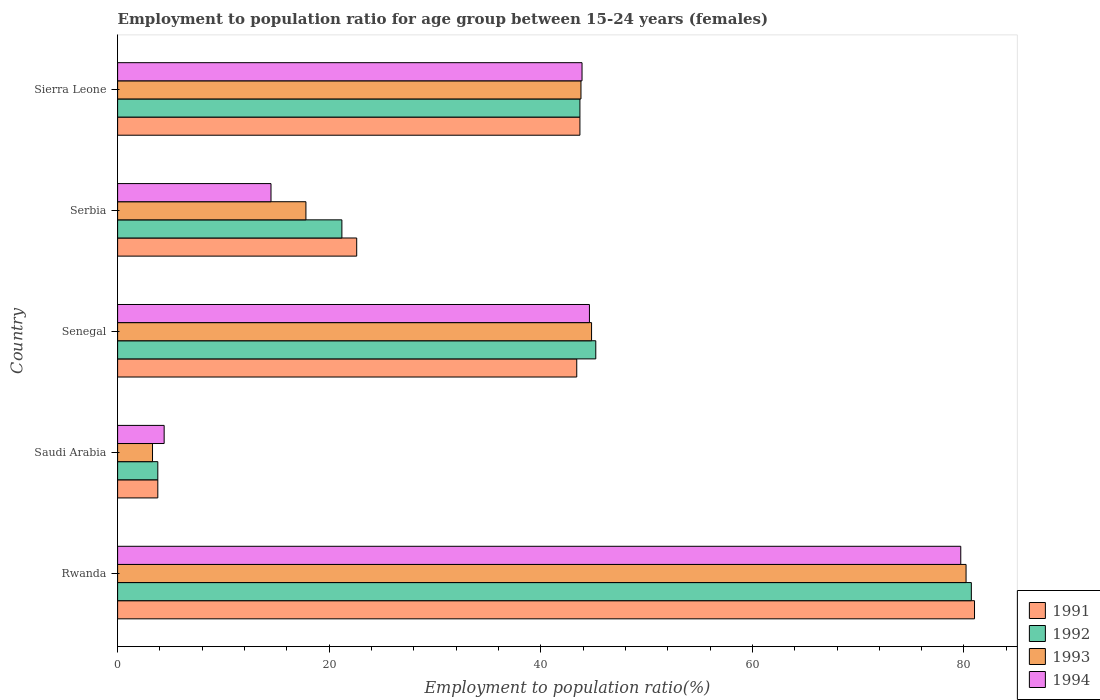How many different coloured bars are there?
Ensure brevity in your answer.  4. How many groups of bars are there?
Ensure brevity in your answer.  5. Are the number of bars per tick equal to the number of legend labels?
Provide a short and direct response. Yes. Are the number of bars on each tick of the Y-axis equal?
Make the answer very short. Yes. What is the label of the 3rd group of bars from the top?
Make the answer very short. Senegal. In how many cases, is the number of bars for a given country not equal to the number of legend labels?
Your answer should be compact. 0. What is the employment to population ratio in 1994 in Senegal?
Your answer should be compact. 44.6. Across all countries, what is the maximum employment to population ratio in 1994?
Your answer should be compact. 79.7. Across all countries, what is the minimum employment to population ratio in 1991?
Your answer should be compact. 3.8. In which country was the employment to population ratio in 1992 maximum?
Your answer should be very brief. Rwanda. In which country was the employment to population ratio in 1992 minimum?
Keep it short and to the point. Saudi Arabia. What is the total employment to population ratio in 1994 in the graph?
Provide a succinct answer. 187.1. What is the difference between the employment to population ratio in 1991 in Rwanda and that in Sierra Leone?
Your answer should be very brief. 37.3. What is the difference between the employment to population ratio in 1994 in Rwanda and the employment to population ratio in 1992 in Senegal?
Offer a terse response. 34.5. What is the average employment to population ratio in 1992 per country?
Offer a very short reply. 38.92. What is the difference between the employment to population ratio in 1994 and employment to population ratio in 1993 in Sierra Leone?
Keep it short and to the point. 0.1. What is the ratio of the employment to population ratio in 1993 in Rwanda to that in Serbia?
Give a very brief answer. 4.51. Is the employment to population ratio in 1991 in Serbia less than that in Sierra Leone?
Offer a very short reply. Yes. Is the difference between the employment to population ratio in 1994 in Senegal and Sierra Leone greater than the difference between the employment to population ratio in 1993 in Senegal and Sierra Leone?
Provide a succinct answer. No. What is the difference between the highest and the second highest employment to population ratio in 1992?
Keep it short and to the point. 35.5. What is the difference between the highest and the lowest employment to population ratio in 1994?
Your response must be concise. 75.3. Is it the case that in every country, the sum of the employment to population ratio in 1994 and employment to population ratio in 1992 is greater than the sum of employment to population ratio in 1993 and employment to population ratio in 1991?
Offer a very short reply. No. Is it the case that in every country, the sum of the employment to population ratio in 1993 and employment to population ratio in 1991 is greater than the employment to population ratio in 1992?
Give a very brief answer. Yes. How many bars are there?
Make the answer very short. 20. Does the graph contain any zero values?
Your answer should be compact. No. Where does the legend appear in the graph?
Provide a short and direct response. Bottom right. How are the legend labels stacked?
Provide a short and direct response. Vertical. What is the title of the graph?
Offer a very short reply. Employment to population ratio for age group between 15-24 years (females). What is the Employment to population ratio(%) in 1992 in Rwanda?
Give a very brief answer. 80.7. What is the Employment to population ratio(%) of 1993 in Rwanda?
Your answer should be very brief. 80.2. What is the Employment to population ratio(%) in 1994 in Rwanda?
Make the answer very short. 79.7. What is the Employment to population ratio(%) in 1991 in Saudi Arabia?
Keep it short and to the point. 3.8. What is the Employment to population ratio(%) of 1992 in Saudi Arabia?
Keep it short and to the point. 3.8. What is the Employment to population ratio(%) in 1993 in Saudi Arabia?
Make the answer very short. 3.3. What is the Employment to population ratio(%) in 1994 in Saudi Arabia?
Your answer should be very brief. 4.4. What is the Employment to population ratio(%) of 1991 in Senegal?
Provide a succinct answer. 43.4. What is the Employment to population ratio(%) of 1992 in Senegal?
Ensure brevity in your answer.  45.2. What is the Employment to population ratio(%) in 1993 in Senegal?
Ensure brevity in your answer.  44.8. What is the Employment to population ratio(%) of 1994 in Senegal?
Offer a terse response. 44.6. What is the Employment to population ratio(%) in 1991 in Serbia?
Offer a terse response. 22.6. What is the Employment to population ratio(%) in 1992 in Serbia?
Ensure brevity in your answer.  21.2. What is the Employment to population ratio(%) in 1993 in Serbia?
Give a very brief answer. 17.8. What is the Employment to population ratio(%) of 1994 in Serbia?
Provide a succinct answer. 14.5. What is the Employment to population ratio(%) in 1991 in Sierra Leone?
Keep it short and to the point. 43.7. What is the Employment to population ratio(%) in 1992 in Sierra Leone?
Give a very brief answer. 43.7. What is the Employment to population ratio(%) in 1993 in Sierra Leone?
Your answer should be compact. 43.8. What is the Employment to population ratio(%) of 1994 in Sierra Leone?
Ensure brevity in your answer.  43.9. Across all countries, what is the maximum Employment to population ratio(%) of 1991?
Your answer should be very brief. 81. Across all countries, what is the maximum Employment to population ratio(%) of 1992?
Keep it short and to the point. 80.7. Across all countries, what is the maximum Employment to population ratio(%) in 1993?
Offer a very short reply. 80.2. Across all countries, what is the maximum Employment to population ratio(%) in 1994?
Make the answer very short. 79.7. Across all countries, what is the minimum Employment to population ratio(%) in 1991?
Provide a short and direct response. 3.8. Across all countries, what is the minimum Employment to population ratio(%) in 1992?
Offer a very short reply. 3.8. Across all countries, what is the minimum Employment to population ratio(%) of 1993?
Give a very brief answer. 3.3. Across all countries, what is the minimum Employment to population ratio(%) of 1994?
Your answer should be compact. 4.4. What is the total Employment to population ratio(%) in 1991 in the graph?
Your answer should be very brief. 194.5. What is the total Employment to population ratio(%) of 1992 in the graph?
Give a very brief answer. 194.6. What is the total Employment to population ratio(%) in 1993 in the graph?
Your response must be concise. 189.9. What is the total Employment to population ratio(%) in 1994 in the graph?
Provide a short and direct response. 187.1. What is the difference between the Employment to population ratio(%) in 1991 in Rwanda and that in Saudi Arabia?
Provide a short and direct response. 77.2. What is the difference between the Employment to population ratio(%) of 1992 in Rwanda and that in Saudi Arabia?
Make the answer very short. 76.9. What is the difference between the Employment to population ratio(%) in 1993 in Rwanda and that in Saudi Arabia?
Your response must be concise. 76.9. What is the difference between the Employment to population ratio(%) in 1994 in Rwanda and that in Saudi Arabia?
Offer a terse response. 75.3. What is the difference between the Employment to population ratio(%) of 1991 in Rwanda and that in Senegal?
Make the answer very short. 37.6. What is the difference between the Employment to population ratio(%) of 1992 in Rwanda and that in Senegal?
Give a very brief answer. 35.5. What is the difference between the Employment to population ratio(%) in 1993 in Rwanda and that in Senegal?
Your response must be concise. 35.4. What is the difference between the Employment to population ratio(%) of 1994 in Rwanda and that in Senegal?
Provide a succinct answer. 35.1. What is the difference between the Employment to population ratio(%) in 1991 in Rwanda and that in Serbia?
Offer a very short reply. 58.4. What is the difference between the Employment to population ratio(%) in 1992 in Rwanda and that in Serbia?
Ensure brevity in your answer.  59.5. What is the difference between the Employment to population ratio(%) of 1993 in Rwanda and that in Serbia?
Offer a terse response. 62.4. What is the difference between the Employment to population ratio(%) in 1994 in Rwanda and that in Serbia?
Provide a short and direct response. 65.2. What is the difference between the Employment to population ratio(%) in 1991 in Rwanda and that in Sierra Leone?
Ensure brevity in your answer.  37.3. What is the difference between the Employment to population ratio(%) in 1992 in Rwanda and that in Sierra Leone?
Your answer should be very brief. 37. What is the difference between the Employment to population ratio(%) in 1993 in Rwanda and that in Sierra Leone?
Give a very brief answer. 36.4. What is the difference between the Employment to population ratio(%) in 1994 in Rwanda and that in Sierra Leone?
Your answer should be very brief. 35.8. What is the difference between the Employment to population ratio(%) in 1991 in Saudi Arabia and that in Senegal?
Offer a terse response. -39.6. What is the difference between the Employment to population ratio(%) in 1992 in Saudi Arabia and that in Senegal?
Keep it short and to the point. -41.4. What is the difference between the Employment to population ratio(%) in 1993 in Saudi Arabia and that in Senegal?
Ensure brevity in your answer.  -41.5. What is the difference between the Employment to population ratio(%) in 1994 in Saudi Arabia and that in Senegal?
Provide a short and direct response. -40.2. What is the difference between the Employment to population ratio(%) of 1991 in Saudi Arabia and that in Serbia?
Give a very brief answer. -18.8. What is the difference between the Employment to population ratio(%) in 1992 in Saudi Arabia and that in Serbia?
Your answer should be compact. -17.4. What is the difference between the Employment to population ratio(%) of 1993 in Saudi Arabia and that in Serbia?
Provide a succinct answer. -14.5. What is the difference between the Employment to population ratio(%) of 1994 in Saudi Arabia and that in Serbia?
Provide a succinct answer. -10.1. What is the difference between the Employment to population ratio(%) of 1991 in Saudi Arabia and that in Sierra Leone?
Provide a succinct answer. -39.9. What is the difference between the Employment to population ratio(%) of 1992 in Saudi Arabia and that in Sierra Leone?
Your answer should be compact. -39.9. What is the difference between the Employment to population ratio(%) in 1993 in Saudi Arabia and that in Sierra Leone?
Your response must be concise. -40.5. What is the difference between the Employment to population ratio(%) of 1994 in Saudi Arabia and that in Sierra Leone?
Keep it short and to the point. -39.5. What is the difference between the Employment to population ratio(%) in 1991 in Senegal and that in Serbia?
Ensure brevity in your answer.  20.8. What is the difference between the Employment to population ratio(%) in 1994 in Senegal and that in Serbia?
Provide a succinct answer. 30.1. What is the difference between the Employment to population ratio(%) of 1991 in Serbia and that in Sierra Leone?
Provide a succinct answer. -21.1. What is the difference between the Employment to population ratio(%) in 1992 in Serbia and that in Sierra Leone?
Give a very brief answer. -22.5. What is the difference between the Employment to population ratio(%) in 1993 in Serbia and that in Sierra Leone?
Give a very brief answer. -26. What is the difference between the Employment to population ratio(%) in 1994 in Serbia and that in Sierra Leone?
Provide a short and direct response. -29.4. What is the difference between the Employment to population ratio(%) of 1991 in Rwanda and the Employment to population ratio(%) of 1992 in Saudi Arabia?
Your response must be concise. 77.2. What is the difference between the Employment to population ratio(%) in 1991 in Rwanda and the Employment to population ratio(%) in 1993 in Saudi Arabia?
Your answer should be compact. 77.7. What is the difference between the Employment to population ratio(%) of 1991 in Rwanda and the Employment to population ratio(%) of 1994 in Saudi Arabia?
Provide a succinct answer. 76.6. What is the difference between the Employment to population ratio(%) of 1992 in Rwanda and the Employment to population ratio(%) of 1993 in Saudi Arabia?
Offer a very short reply. 77.4. What is the difference between the Employment to population ratio(%) in 1992 in Rwanda and the Employment to population ratio(%) in 1994 in Saudi Arabia?
Ensure brevity in your answer.  76.3. What is the difference between the Employment to population ratio(%) of 1993 in Rwanda and the Employment to population ratio(%) of 1994 in Saudi Arabia?
Your answer should be compact. 75.8. What is the difference between the Employment to population ratio(%) in 1991 in Rwanda and the Employment to population ratio(%) in 1992 in Senegal?
Give a very brief answer. 35.8. What is the difference between the Employment to population ratio(%) in 1991 in Rwanda and the Employment to population ratio(%) in 1993 in Senegal?
Ensure brevity in your answer.  36.2. What is the difference between the Employment to population ratio(%) in 1991 in Rwanda and the Employment to population ratio(%) in 1994 in Senegal?
Your answer should be compact. 36.4. What is the difference between the Employment to population ratio(%) of 1992 in Rwanda and the Employment to population ratio(%) of 1993 in Senegal?
Provide a short and direct response. 35.9. What is the difference between the Employment to population ratio(%) in 1992 in Rwanda and the Employment to population ratio(%) in 1994 in Senegal?
Your answer should be compact. 36.1. What is the difference between the Employment to population ratio(%) of 1993 in Rwanda and the Employment to population ratio(%) of 1994 in Senegal?
Your answer should be very brief. 35.6. What is the difference between the Employment to population ratio(%) in 1991 in Rwanda and the Employment to population ratio(%) in 1992 in Serbia?
Your answer should be compact. 59.8. What is the difference between the Employment to population ratio(%) of 1991 in Rwanda and the Employment to population ratio(%) of 1993 in Serbia?
Your response must be concise. 63.2. What is the difference between the Employment to population ratio(%) of 1991 in Rwanda and the Employment to population ratio(%) of 1994 in Serbia?
Your answer should be very brief. 66.5. What is the difference between the Employment to population ratio(%) in 1992 in Rwanda and the Employment to population ratio(%) in 1993 in Serbia?
Provide a succinct answer. 62.9. What is the difference between the Employment to population ratio(%) of 1992 in Rwanda and the Employment to population ratio(%) of 1994 in Serbia?
Give a very brief answer. 66.2. What is the difference between the Employment to population ratio(%) of 1993 in Rwanda and the Employment to population ratio(%) of 1994 in Serbia?
Offer a very short reply. 65.7. What is the difference between the Employment to population ratio(%) of 1991 in Rwanda and the Employment to population ratio(%) of 1992 in Sierra Leone?
Keep it short and to the point. 37.3. What is the difference between the Employment to population ratio(%) of 1991 in Rwanda and the Employment to population ratio(%) of 1993 in Sierra Leone?
Your response must be concise. 37.2. What is the difference between the Employment to population ratio(%) in 1991 in Rwanda and the Employment to population ratio(%) in 1994 in Sierra Leone?
Offer a very short reply. 37.1. What is the difference between the Employment to population ratio(%) in 1992 in Rwanda and the Employment to population ratio(%) in 1993 in Sierra Leone?
Provide a succinct answer. 36.9. What is the difference between the Employment to population ratio(%) of 1992 in Rwanda and the Employment to population ratio(%) of 1994 in Sierra Leone?
Give a very brief answer. 36.8. What is the difference between the Employment to population ratio(%) in 1993 in Rwanda and the Employment to population ratio(%) in 1994 in Sierra Leone?
Provide a succinct answer. 36.3. What is the difference between the Employment to population ratio(%) of 1991 in Saudi Arabia and the Employment to population ratio(%) of 1992 in Senegal?
Ensure brevity in your answer.  -41.4. What is the difference between the Employment to population ratio(%) of 1991 in Saudi Arabia and the Employment to population ratio(%) of 1993 in Senegal?
Offer a very short reply. -41. What is the difference between the Employment to population ratio(%) of 1991 in Saudi Arabia and the Employment to population ratio(%) of 1994 in Senegal?
Your answer should be very brief. -40.8. What is the difference between the Employment to population ratio(%) of 1992 in Saudi Arabia and the Employment to population ratio(%) of 1993 in Senegal?
Your response must be concise. -41. What is the difference between the Employment to population ratio(%) of 1992 in Saudi Arabia and the Employment to population ratio(%) of 1994 in Senegal?
Ensure brevity in your answer.  -40.8. What is the difference between the Employment to population ratio(%) of 1993 in Saudi Arabia and the Employment to population ratio(%) of 1994 in Senegal?
Provide a succinct answer. -41.3. What is the difference between the Employment to population ratio(%) of 1991 in Saudi Arabia and the Employment to population ratio(%) of 1992 in Serbia?
Offer a terse response. -17.4. What is the difference between the Employment to population ratio(%) in 1991 in Saudi Arabia and the Employment to population ratio(%) in 1993 in Serbia?
Offer a very short reply. -14. What is the difference between the Employment to population ratio(%) of 1993 in Saudi Arabia and the Employment to population ratio(%) of 1994 in Serbia?
Keep it short and to the point. -11.2. What is the difference between the Employment to population ratio(%) of 1991 in Saudi Arabia and the Employment to population ratio(%) of 1992 in Sierra Leone?
Give a very brief answer. -39.9. What is the difference between the Employment to population ratio(%) in 1991 in Saudi Arabia and the Employment to population ratio(%) in 1993 in Sierra Leone?
Your answer should be compact. -40. What is the difference between the Employment to population ratio(%) of 1991 in Saudi Arabia and the Employment to population ratio(%) of 1994 in Sierra Leone?
Provide a short and direct response. -40.1. What is the difference between the Employment to population ratio(%) in 1992 in Saudi Arabia and the Employment to population ratio(%) in 1994 in Sierra Leone?
Provide a short and direct response. -40.1. What is the difference between the Employment to population ratio(%) of 1993 in Saudi Arabia and the Employment to population ratio(%) of 1994 in Sierra Leone?
Make the answer very short. -40.6. What is the difference between the Employment to population ratio(%) of 1991 in Senegal and the Employment to population ratio(%) of 1992 in Serbia?
Your answer should be compact. 22.2. What is the difference between the Employment to population ratio(%) of 1991 in Senegal and the Employment to population ratio(%) of 1993 in Serbia?
Offer a terse response. 25.6. What is the difference between the Employment to population ratio(%) in 1991 in Senegal and the Employment to population ratio(%) in 1994 in Serbia?
Offer a terse response. 28.9. What is the difference between the Employment to population ratio(%) of 1992 in Senegal and the Employment to population ratio(%) of 1993 in Serbia?
Give a very brief answer. 27.4. What is the difference between the Employment to population ratio(%) in 1992 in Senegal and the Employment to population ratio(%) in 1994 in Serbia?
Provide a short and direct response. 30.7. What is the difference between the Employment to population ratio(%) of 1993 in Senegal and the Employment to population ratio(%) of 1994 in Serbia?
Your answer should be compact. 30.3. What is the difference between the Employment to population ratio(%) of 1991 in Senegal and the Employment to population ratio(%) of 1992 in Sierra Leone?
Give a very brief answer. -0.3. What is the difference between the Employment to population ratio(%) of 1991 in Senegal and the Employment to population ratio(%) of 1993 in Sierra Leone?
Provide a short and direct response. -0.4. What is the difference between the Employment to population ratio(%) in 1992 in Senegal and the Employment to population ratio(%) in 1993 in Sierra Leone?
Give a very brief answer. 1.4. What is the difference between the Employment to population ratio(%) of 1992 in Senegal and the Employment to population ratio(%) of 1994 in Sierra Leone?
Provide a short and direct response. 1.3. What is the difference between the Employment to population ratio(%) of 1993 in Senegal and the Employment to population ratio(%) of 1994 in Sierra Leone?
Ensure brevity in your answer.  0.9. What is the difference between the Employment to population ratio(%) in 1991 in Serbia and the Employment to population ratio(%) in 1992 in Sierra Leone?
Your response must be concise. -21.1. What is the difference between the Employment to population ratio(%) in 1991 in Serbia and the Employment to population ratio(%) in 1993 in Sierra Leone?
Ensure brevity in your answer.  -21.2. What is the difference between the Employment to population ratio(%) of 1991 in Serbia and the Employment to population ratio(%) of 1994 in Sierra Leone?
Make the answer very short. -21.3. What is the difference between the Employment to population ratio(%) of 1992 in Serbia and the Employment to population ratio(%) of 1993 in Sierra Leone?
Your response must be concise. -22.6. What is the difference between the Employment to population ratio(%) in 1992 in Serbia and the Employment to population ratio(%) in 1994 in Sierra Leone?
Provide a succinct answer. -22.7. What is the difference between the Employment to population ratio(%) of 1993 in Serbia and the Employment to population ratio(%) of 1994 in Sierra Leone?
Offer a very short reply. -26.1. What is the average Employment to population ratio(%) in 1991 per country?
Provide a succinct answer. 38.9. What is the average Employment to population ratio(%) in 1992 per country?
Your answer should be compact. 38.92. What is the average Employment to population ratio(%) of 1993 per country?
Your response must be concise. 37.98. What is the average Employment to population ratio(%) in 1994 per country?
Make the answer very short. 37.42. What is the difference between the Employment to population ratio(%) of 1991 and Employment to population ratio(%) of 1992 in Rwanda?
Give a very brief answer. 0.3. What is the difference between the Employment to population ratio(%) of 1992 and Employment to population ratio(%) of 1993 in Rwanda?
Offer a terse response. 0.5. What is the difference between the Employment to population ratio(%) of 1991 and Employment to population ratio(%) of 1993 in Saudi Arabia?
Your answer should be very brief. 0.5. What is the difference between the Employment to population ratio(%) of 1992 and Employment to population ratio(%) of 1994 in Saudi Arabia?
Give a very brief answer. -0.6. What is the difference between the Employment to population ratio(%) of 1993 and Employment to population ratio(%) of 1994 in Saudi Arabia?
Your answer should be compact. -1.1. What is the difference between the Employment to population ratio(%) in 1991 and Employment to population ratio(%) in 1993 in Senegal?
Provide a succinct answer. -1.4. What is the difference between the Employment to population ratio(%) in 1992 and Employment to population ratio(%) in 1993 in Senegal?
Keep it short and to the point. 0.4. What is the difference between the Employment to population ratio(%) in 1993 and Employment to population ratio(%) in 1994 in Senegal?
Provide a succinct answer. 0.2. What is the difference between the Employment to population ratio(%) in 1991 and Employment to population ratio(%) in 1992 in Serbia?
Provide a succinct answer. 1.4. What is the difference between the Employment to population ratio(%) in 1991 and Employment to population ratio(%) in 1993 in Serbia?
Your answer should be very brief. 4.8. What is the difference between the Employment to population ratio(%) in 1991 and Employment to population ratio(%) in 1994 in Serbia?
Ensure brevity in your answer.  8.1. What is the difference between the Employment to population ratio(%) in 1992 and Employment to population ratio(%) in 1993 in Serbia?
Make the answer very short. 3.4. What is the difference between the Employment to population ratio(%) of 1991 and Employment to population ratio(%) of 1994 in Sierra Leone?
Keep it short and to the point. -0.2. What is the difference between the Employment to population ratio(%) of 1992 and Employment to population ratio(%) of 1994 in Sierra Leone?
Ensure brevity in your answer.  -0.2. What is the ratio of the Employment to population ratio(%) in 1991 in Rwanda to that in Saudi Arabia?
Your answer should be very brief. 21.32. What is the ratio of the Employment to population ratio(%) of 1992 in Rwanda to that in Saudi Arabia?
Your response must be concise. 21.24. What is the ratio of the Employment to population ratio(%) in 1993 in Rwanda to that in Saudi Arabia?
Provide a short and direct response. 24.3. What is the ratio of the Employment to population ratio(%) in 1994 in Rwanda to that in Saudi Arabia?
Give a very brief answer. 18.11. What is the ratio of the Employment to population ratio(%) of 1991 in Rwanda to that in Senegal?
Ensure brevity in your answer.  1.87. What is the ratio of the Employment to population ratio(%) in 1992 in Rwanda to that in Senegal?
Your answer should be compact. 1.79. What is the ratio of the Employment to population ratio(%) of 1993 in Rwanda to that in Senegal?
Keep it short and to the point. 1.79. What is the ratio of the Employment to population ratio(%) in 1994 in Rwanda to that in Senegal?
Make the answer very short. 1.79. What is the ratio of the Employment to population ratio(%) of 1991 in Rwanda to that in Serbia?
Provide a short and direct response. 3.58. What is the ratio of the Employment to population ratio(%) of 1992 in Rwanda to that in Serbia?
Your response must be concise. 3.81. What is the ratio of the Employment to population ratio(%) of 1993 in Rwanda to that in Serbia?
Your answer should be compact. 4.51. What is the ratio of the Employment to population ratio(%) in 1994 in Rwanda to that in Serbia?
Provide a succinct answer. 5.5. What is the ratio of the Employment to population ratio(%) in 1991 in Rwanda to that in Sierra Leone?
Offer a very short reply. 1.85. What is the ratio of the Employment to population ratio(%) of 1992 in Rwanda to that in Sierra Leone?
Keep it short and to the point. 1.85. What is the ratio of the Employment to population ratio(%) in 1993 in Rwanda to that in Sierra Leone?
Your answer should be very brief. 1.83. What is the ratio of the Employment to population ratio(%) of 1994 in Rwanda to that in Sierra Leone?
Your response must be concise. 1.82. What is the ratio of the Employment to population ratio(%) of 1991 in Saudi Arabia to that in Senegal?
Your response must be concise. 0.09. What is the ratio of the Employment to population ratio(%) of 1992 in Saudi Arabia to that in Senegal?
Provide a short and direct response. 0.08. What is the ratio of the Employment to population ratio(%) in 1993 in Saudi Arabia to that in Senegal?
Offer a terse response. 0.07. What is the ratio of the Employment to population ratio(%) of 1994 in Saudi Arabia to that in Senegal?
Offer a terse response. 0.1. What is the ratio of the Employment to population ratio(%) of 1991 in Saudi Arabia to that in Serbia?
Your answer should be compact. 0.17. What is the ratio of the Employment to population ratio(%) of 1992 in Saudi Arabia to that in Serbia?
Your answer should be very brief. 0.18. What is the ratio of the Employment to population ratio(%) in 1993 in Saudi Arabia to that in Serbia?
Your answer should be very brief. 0.19. What is the ratio of the Employment to population ratio(%) of 1994 in Saudi Arabia to that in Serbia?
Keep it short and to the point. 0.3. What is the ratio of the Employment to population ratio(%) in 1991 in Saudi Arabia to that in Sierra Leone?
Give a very brief answer. 0.09. What is the ratio of the Employment to population ratio(%) in 1992 in Saudi Arabia to that in Sierra Leone?
Offer a very short reply. 0.09. What is the ratio of the Employment to population ratio(%) of 1993 in Saudi Arabia to that in Sierra Leone?
Make the answer very short. 0.08. What is the ratio of the Employment to population ratio(%) of 1994 in Saudi Arabia to that in Sierra Leone?
Provide a succinct answer. 0.1. What is the ratio of the Employment to population ratio(%) in 1991 in Senegal to that in Serbia?
Your answer should be compact. 1.92. What is the ratio of the Employment to population ratio(%) in 1992 in Senegal to that in Serbia?
Ensure brevity in your answer.  2.13. What is the ratio of the Employment to population ratio(%) of 1993 in Senegal to that in Serbia?
Offer a very short reply. 2.52. What is the ratio of the Employment to population ratio(%) in 1994 in Senegal to that in Serbia?
Your answer should be very brief. 3.08. What is the ratio of the Employment to population ratio(%) in 1991 in Senegal to that in Sierra Leone?
Provide a short and direct response. 0.99. What is the ratio of the Employment to population ratio(%) of 1992 in Senegal to that in Sierra Leone?
Provide a short and direct response. 1.03. What is the ratio of the Employment to population ratio(%) of 1993 in Senegal to that in Sierra Leone?
Keep it short and to the point. 1.02. What is the ratio of the Employment to population ratio(%) of 1994 in Senegal to that in Sierra Leone?
Provide a succinct answer. 1.02. What is the ratio of the Employment to population ratio(%) of 1991 in Serbia to that in Sierra Leone?
Your answer should be very brief. 0.52. What is the ratio of the Employment to population ratio(%) of 1992 in Serbia to that in Sierra Leone?
Provide a short and direct response. 0.49. What is the ratio of the Employment to population ratio(%) of 1993 in Serbia to that in Sierra Leone?
Offer a terse response. 0.41. What is the ratio of the Employment to population ratio(%) in 1994 in Serbia to that in Sierra Leone?
Offer a terse response. 0.33. What is the difference between the highest and the second highest Employment to population ratio(%) in 1991?
Offer a terse response. 37.3. What is the difference between the highest and the second highest Employment to population ratio(%) of 1992?
Your response must be concise. 35.5. What is the difference between the highest and the second highest Employment to population ratio(%) of 1993?
Offer a very short reply. 35.4. What is the difference between the highest and the second highest Employment to population ratio(%) in 1994?
Offer a very short reply. 35.1. What is the difference between the highest and the lowest Employment to population ratio(%) in 1991?
Ensure brevity in your answer.  77.2. What is the difference between the highest and the lowest Employment to population ratio(%) in 1992?
Make the answer very short. 76.9. What is the difference between the highest and the lowest Employment to population ratio(%) of 1993?
Keep it short and to the point. 76.9. What is the difference between the highest and the lowest Employment to population ratio(%) of 1994?
Offer a very short reply. 75.3. 